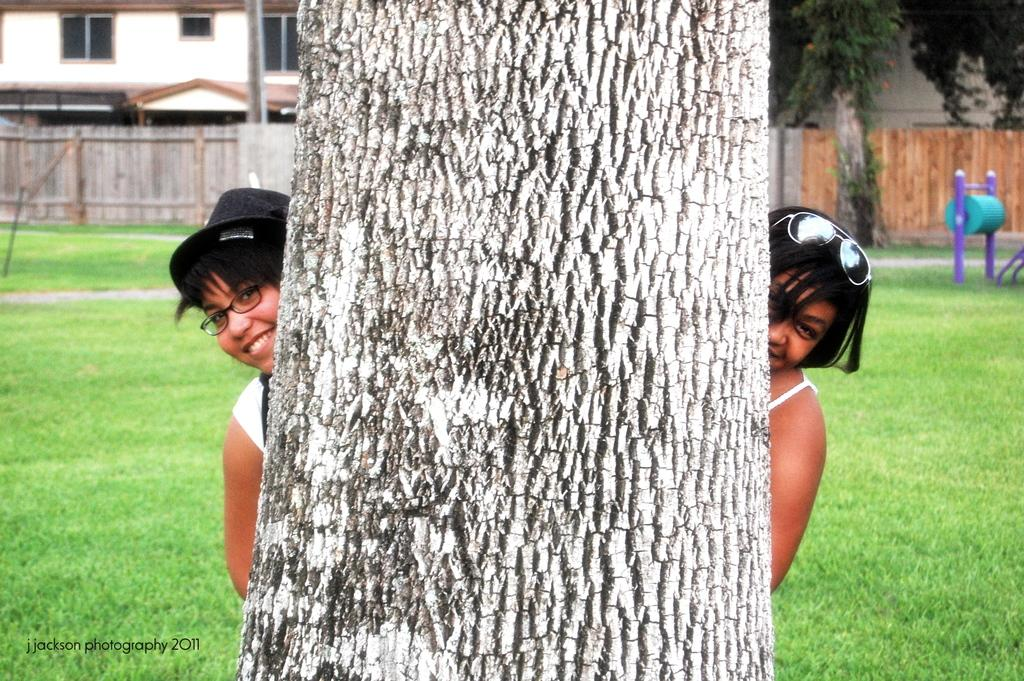How many women are in the image? There are two women in the image. Where are the women located in relation to the tree? The women are standing behind a tree. What can be seen in the background of the image? There is a fence, buildings, grass, trees, and other objects on the ground visible in the background of the image. What is the name of the carpenter who built the tree in the image? There is no carpenter mentioned in the image, and trees are not built by carpenters; they grow naturally. 